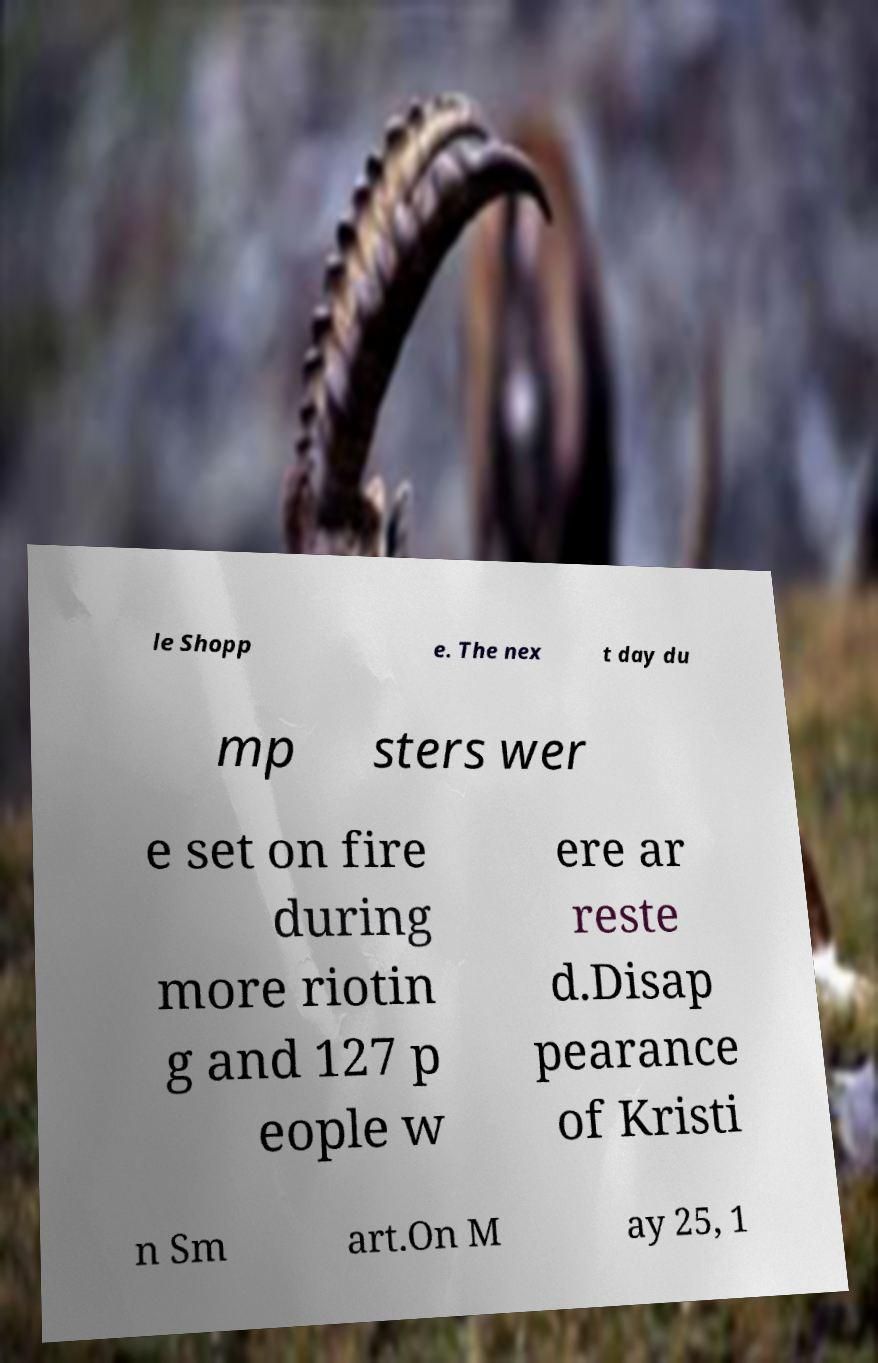I need the written content from this picture converted into text. Can you do that? le Shopp e. The nex t day du mp sters wer e set on fire during more riotin g and 127 p eople w ere ar reste d.Disap pearance of Kristi n Sm art.On M ay 25, 1 